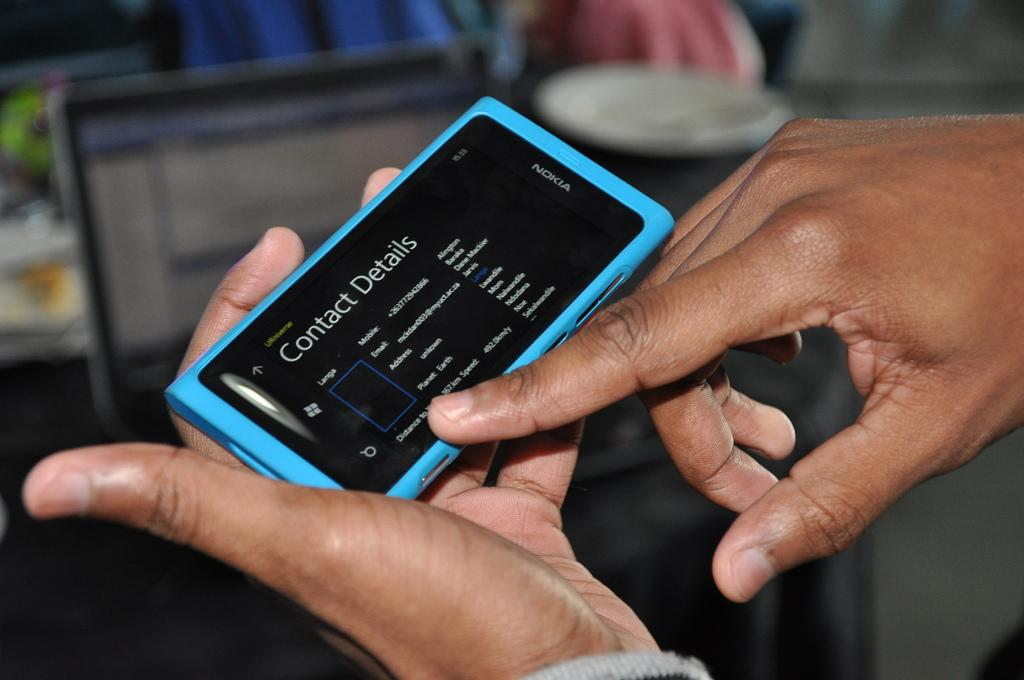<image>
Give a short and clear explanation of the subsequent image. A person checks the details of one of his contacts on his phone. 